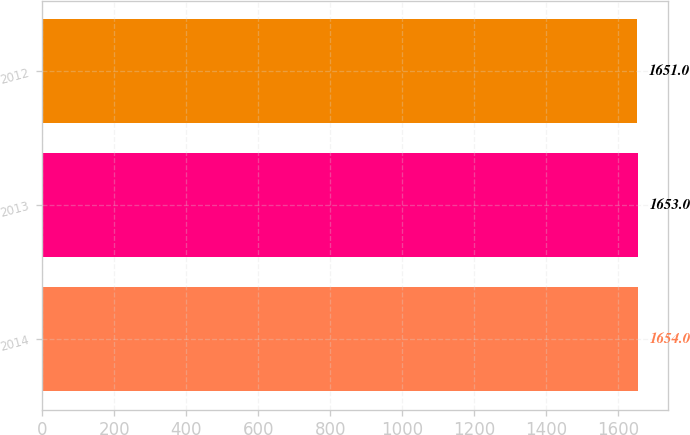Convert chart. <chart><loc_0><loc_0><loc_500><loc_500><bar_chart><fcel>2014<fcel>2013<fcel>2012<nl><fcel>1654<fcel>1653<fcel>1651<nl></chart> 